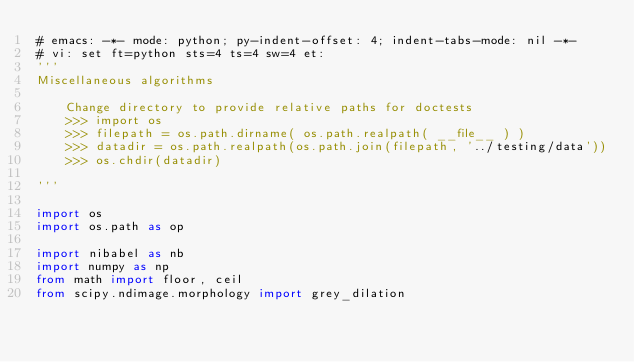<code> <loc_0><loc_0><loc_500><loc_500><_Python_># emacs: -*- mode: python; py-indent-offset: 4; indent-tabs-mode: nil -*-
# vi: set ft=python sts=4 ts=4 sw=4 et:
'''
Miscellaneous algorithms

    Change directory to provide relative paths for doctests
    >>> import os
    >>> filepath = os.path.dirname( os.path.realpath( __file__ ) )
    >>> datadir = os.path.realpath(os.path.join(filepath, '../testing/data'))
    >>> os.chdir(datadir)

'''

import os
import os.path as op

import nibabel as nb
import numpy as np
from math import floor, ceil
from scipy.ndimage.morphology import grey_dilation</code> 